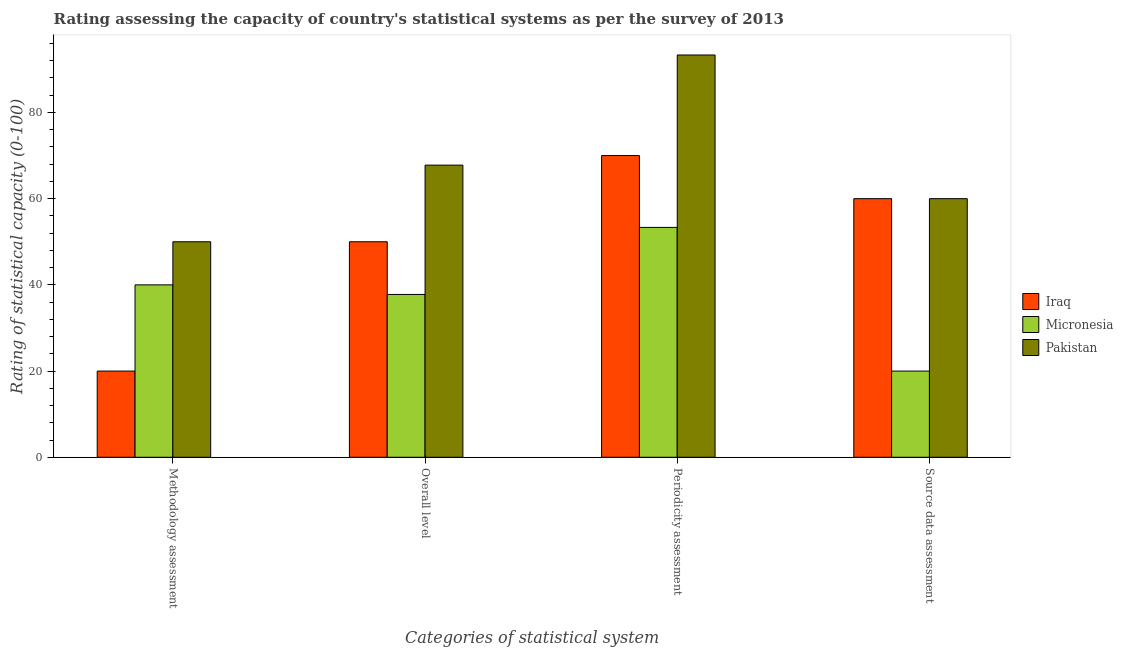How many groups of bars are there?
Keep it short and to the point. 4. Are the number of bars on each tick of the X-axis equal?
Provide a succinct answer. Yes. How many bars are there on the 3rd tick from the left?
Provide a short and direct response. 3. What is the label of the 2nd group of bars from the left?
Provide a short and direct response. Overall level. What is the overall level rating in Micronesia?
Provide a short and direct response. 37.78. Across all countries, what is the maximum methodology assessment rating?
Your answer should be very brief. 50. Across all countries, what is the minimum methodology assessment rating?
Ensure brevity in your answer.  20. In which country was the source data assessment rating maximum?
Offer a terse response. Iraq. In which country was the methodology assessment rating minimum?
Provide a succinct answer. Iraq. What is the total methodology assessment rating in the graph?
Your answer should be very brief. 110. What is the difference between the overall level rating in Micronesia and that in Iraq?
Keep it short and to the point. -12.22. What is the difference between the periodicity assessment rating in Pakistan and the methodology assessment rating in Iraq?
Your response must be concise. 73.33. What is the average methodology assessment rating per country?
Keep it short and to the point. 36.67. What is the difference between the methodology assessment rating and source data assessment rating in Micronesia?
Your response must be concise. 20. What is the ratio of the source data assessment rating in Iraq to that in Micronesia?
Your answer should be compact. 3. What is the difference between the highest and the lowest methodology assessment rating?
Give a very brief answer. 30. Is the sum of the periodicity assessment rating in Pakistan and Iraq greater than the maximum source data assessment rating across all countries?
Provide a succinct answer. Yes. Is it the case that in every country, the sum of the methodology assessment rating and overall level rating is greater than the sum of periodicity assessment rating and source data assessment rating?
Give a very brief answer. No. What does the 1st bar from the left in Source data assessment represents?
Offer a terse response. Iraq. What does the 2nd bar from the right in Source data assessment represents?
Ensure brevity in your answer.  Micronesia. How many bars are there?
Your response must be concise. 12. How many countries are there in the graph?
Provide a short and direct response. 3. What is the difference between two consecutive major ticks on the Y-axis?
Your response must be concise. 20. Does the graph contain grids?
Your answer should be compact. No. Where does the legend appear in the graph?
Your answer should be compact. Center right. How are the legend labels stacked?
Offer a terse response. Vertical. What is the title of the graph?
Provide a succinct answer. Rating assessing the capacity of country's statistical systems as per the survey of 2013 . Does "Turks and Caicos Islands" appear as one of the legend labels in the graph?
Offer a very short reply. No. What is the label or title of the X-axis?
Give a very brief answer. Categories of statistical system. What is the label or title of the Y-axis?
Ensure brevity in your answer.  Rating of statistical capacity (0-100). What is the Rating of statistical capacity (0-100) of Iraq in Methodology assessment?
Your response must be concise. 20. What is the Rating of statistical capacity (0-100) of Micronesia in Methodology assessment?
Your answer should be very brief. 40. What is the Rating of statistical capacity (0-100) of Iraq in Overall level?
Keep it short and to the point. 50. What is the Rating of statistical capacity (0-100) of Micronesia in Overall level?
Your answer should be compact. 37.78. What is the Rating of statistical capacity (0-100) of Pakistan in Overall level?
Offer a very short reply. 67.78. What is the Rating of statistical capacity (0-100) in Iraq in Periodicity assessment?
Provide a succinct answer. 70. What is the Rating of statistical capacity (0-100) in Micronesia in Periodicity assessment?
Give a very brief answer. 53.33. What is the Rating of statistical capacity (0-100) of Pakistan in Periodicity assessment?
Your answer should be very brief. 93.33. What is the Rating of statistical capacity (0-100) of Iraq in Source data assessment?
Ensure brevity in your answer.  60. What is the Rating of statistical capacity (0-100) of Pakistan in Source data assessment?
Provide a short and direct response. 60. Across all Categories of statistical system, what is the maximum Rating of statistical capacity (0-100) in Micronesia?
Provide a short and direct response. 53.33. Across all Categories of statistical system, what is the maximum Rating of statistical capacity (0-100) in Pakistan?
Keep it short and to the point. 93.33. Across all Categories of statistical system, what is the minimum Rating of statistical capacity (0-100) in Iraq?
Offer a terse response. 20. Across all Categories of statistical system, what is the minimum Rating of statistical capacity (0-100) of Pakistan?
Your answer should be very brief. 50. What is the total Rating of statistical capacity (0-100) of Iraq in the graph?
Keep it short and to the point. 200. What is the total Rating of statistical capacity (0-100) in Micronesia in the graph?
Give a very brief answer. 151.11. What is the total Rating of statistical capacity (0-100) of Pakistan in the graph?
Give a very brief answer. 271.11. What is the difference between the Rating of statistical capacity (0-100) of Micronesia in Methodology assessment and that in Overall level?
Keep it short and to the point. 2.22. What is the difference between the Rating of statistical capacity (0-100) in Pakistan in Methodology assessment and that in Overall level?
Give a very brief answer. -17.78. What is the difference between the Rating of statistical capacity (0-100) in Micronesia in Methodology assessment and that in Periodicity assessment?
Provide a succinct answer. -13.33. What is the difference between the Rating of statistical capacity (0-100) of Pakistan in Methodology assessment and that in Periodicity assessment?
Ensure brevity in your answer.  -43.33. What is the difference between the Rating of statistical capacity (0-100) in Iraq in Methodology assessment and that in Source data assessment?
Offer a very short reply. -40. What is the difference between the Rating of statistical capacity (0-100) in Micronesia in Methodology assessment and that in Source data assessment?
Your answer should be very brief. 20. What is the difference between the Rating of statistical capacity (0-100) in Pakistan in Methodology assessment and that in Source data assessment?
Provide a succinct answer. -10. What is the difference between the Rating of statistical capacity (0-100) of Iraq in Overall level and that in Periodicity assessment?
Your answer should be very brief. -20. What is the difference between the Rating of statistical capacity (0-100) in Micronesia in Overall level and that in Periodicity assessment?
Keep it short and to the point. -15.56. What is the difference between the Rating of statistical capacity (0-100) of Pakistan in Overall level and that in Periodicity assessment?
Provide a short and direct response. -25.56. What is the difference between the Rating of statistical capacity (0-100) in Iraq in Overall level and that in Source data assessment?
Keep it short and to the point. -10. What is the difference between the Rating of statistical capacity (0-100) in Micronesia in Overall level and that in Source data assessment?
Offer a very short reply. 17.78. What is the difference between the Rating of statistical capacity (0-100) of Pakistan in Overall level and that in Source data assessment?
Provide a succinct answer. 7.78. What is the difference between the Rating of statistical capacity (0-100) of Micronesia in Periodicity assessment and that in Source data assessment?
Offer a very short reply. 33.33. What is the difference between the Rating of statistical capacity (0-100) in Pakistan in Periodicity assessment and that in Source data assessment?
Your answer should be very brief. 33.33. What is the difference between the Rating of statistical capacity (0-100) of Iraq in Methodology assessment and the Rating of statistical capacity (0-100) of Micronesia in Overall level?
Ensure brevity in your answer.  -17.78. What is the difference between the Rating of statistical capacity (0-100) in Iraq in Methodology assessment and the Rating of statistical capacity (0-100) in Pakistan in Overall level?
Your answer should be very brief. -47.78. What is the difference between the Rating of statistical capacity (0-100) of Micronesia in Methodology assessment and the Rating of statistical capacity (0-100) of Pakistan in Overall level?
Make the answer very short. -27.78. What is the difference between the Rating of statistical capacity (0-100) of Iraq in Methodology assessment and the Rating of statistical capacity (0-100) of Micronesia in Periodicity assessment?
Make the answer very short. -33.33. What is the difference between the Rating of statistical capacity (0-100) of Iraq in Methodology assessment and the Rating of statistical capacity (0-100) of Pakistan in Periodicity assessment?
Give a very brief answer. -73.33. What is the difference between the Rating of statistical capacity (0-100) of Micronesia in Methodology assessment and the Rating of statistical capacity (0-100) of Pakistan in Periodicity assessment?
Offer a terse response. -53.33. What is the difference between the Rating of statistical capacity (0-100) of Iraq in Overall level and the Rating of statistical capacity (0-100) of Pakistan in Periodicity assessment?
Keep it short and to the point. -43.33. What is the difference between the Rating of statistical capacity (0-100) of Micronesia in Overall level and the Rating of statistical capacity (0-100) of Pakistan in Periodicity assessment?
Your answer should be compact. -55.56. What is the difference between the Rating of statistical capacity (0-100) of Iraq in Overall level and the Rating of statistical capacity (0-100) of Micronesia in Source data assessment?
Provide a succinct answer. 30. What is the difference between the Rating of statistical capacity (0-100) of Micronesia in Overall level and the Rating of statistical capacity (0-100) of Pakistan in Source data assessment?
Your response must be concise. -22.22. What is the difference between the Rating of statistical capacity (0-100) of Iraq in Periodicity assessment and the Rating of statistical capacity (0-100) of Micronesia in Source data assessment?
Your response must be concise. 50. What is the difference between the Rating of statistical capacity (0-100) of Iraq in Periodicity assessment and the Rating of statistical capacity (0-100) of Pakistan in Source data assessment?
Offer a terse response. 10. What is the difference between the Rating of statistical capacity (0-100) in Micronesia in Periodicity assessment and the Rating of statistical capacity (0-100) in Pakistan in Source data assessment?
Provide a succinct answer. -6.67. What is the average Rating of statistical capacity (0-100) in Iraq per Categories of statistical system?
Keep it short and to the point. 50. What is the average Rating of statistical capacity (0-100) in Micronesia per Categories of statistical system?
Offer a very short reply. 37.78. What is the average Rating of statistical capacity (0-100) of Pakistan per Categories of statistical system?
Make the answer very short. 67.78. What is the difference between the Rating of statistical capacity (0-100) in Iraq and Rating of statistical capacity (0-100) in Micronesia in Overall level?
Offer a terse response. 12.22. What is the difference between the Rating of statistical capacity (0-100) of Iraq and Rating of statistical capacity (0-100) of Pakistan in Overall level?
Keep it short and to the point. -17.78. What is the difference between the Rating of statistical capacity (0-100) in Micronesia and Rating of statistical capacity (0-100) in Pakistan in Overall level?
Offer a very short reply. -30. What is the difference between the Rating of statistical capacity (0-100) in Iraq and Rating of statistical capacity (0-100) in Micronesia in Periodicity assessment?
Make the answer very short. 16.67. What is the difference between the Rating of statistical capacity (0-100) of Iraq and Rating of statistical capacity (0-100) of Pakistan in Periodicity assessment?
Offer a terse response. -23.33. What is the ratio of the Rating of statistical capacity (0-100) in Iraq in Methodology assessment to that in Overall level?
Keep it short and to the point. 0.4. What is the ratio of the Rating of statistical capacity (0-100) in Micronesia in Methodology assessment to that in Overall level?
Ensure brevity in your answer.  1.06. What is the ratio of the Rating of statistical capacity (0-100) of Pakistan in Methodology assessment to that in Overall level?
Your answer should be compact. 0.74. What is the ratio of the Rating of statistical capacity (0-100) of Iraq in Methodology assessment to that in Periodicity assessment?
Your response must be concise. 0.29. What is the ratio of the Rating of statistical capacity (0-100) of Micronesia in Methodology assessment to that in Periodicity assessment?
Ensure brevity in your answer.  0.75. What is the ratio of the Rating of statistical capacity (0-100) of Pakistan in Methodology assessment to that in Periodicity assessment?
Your response must be concise. 0.54. What is the ratio of the Rating of statistical capacity (0-100) in Iraq in Overall level to that in Periodicity assessment?
Keep it short and to the point. 0.71. What is the ratio of the Rating of statistical capacity (0-100) of Micronesia in Overall level to that in Periodicity assessment?
Your response must be concise. 0.71. What is the ratio of the Rating of statistical capacity (0-100) in Pakistan in Overall level to that in Periodicity assessment?
Provide a succinct answer. 0.73. What is the ratio of the Rating of statistical capacity (0-100) in Iraq in Overall level to that in Source data assessment?
Make the answer very short. 0.83. What is the ratio of the Rating of statistical capacity (0-100) of Micronesia in Overall level to that in Source data assessment?
Your answer should be very brief. 1.89. What is the ratio of the Rating of statistical capacity (0-100) in Pakistan in Overall level to that in Source data assessment?
Keep it short and to the point. 1.13. What is the ratio of the Rating of statistical capacity (0-100) of Iraq in Periodicity assessment to that in Source data assessment?
Ensure brevity in your answer.  1.17. What is the ratio of the Rating of statistical capacity (0-100) in Micronesia in Periodicity assessment to that in Source data assessment?
Ensure brevity in your answer.  2.67. What is the ratio of the Rating of statistical capacity (0-100) of Pakistan in Periodicity assessment to that in Source data assessment?
Your answer should be compact. 1.56. What is the difference between the highest and the second highest Rating of statistical capacity (0-100) in Micronesia?
Your answer should be compact. 13.33. What is the difference between the highest and the second highest Rating of statistical capacity (0-100) of Pakistan?
Your answer should be compact. 25.56. What is the difference between the highest and the lowest Rating of statistical capacity (0-100) in Micronesia?
Give a very brief answer. 33.33. What is the difference between the highest and the lowest Rating of statistical capacity (0-100) in Pakistan?
Give a very brief answer. 43.33. 